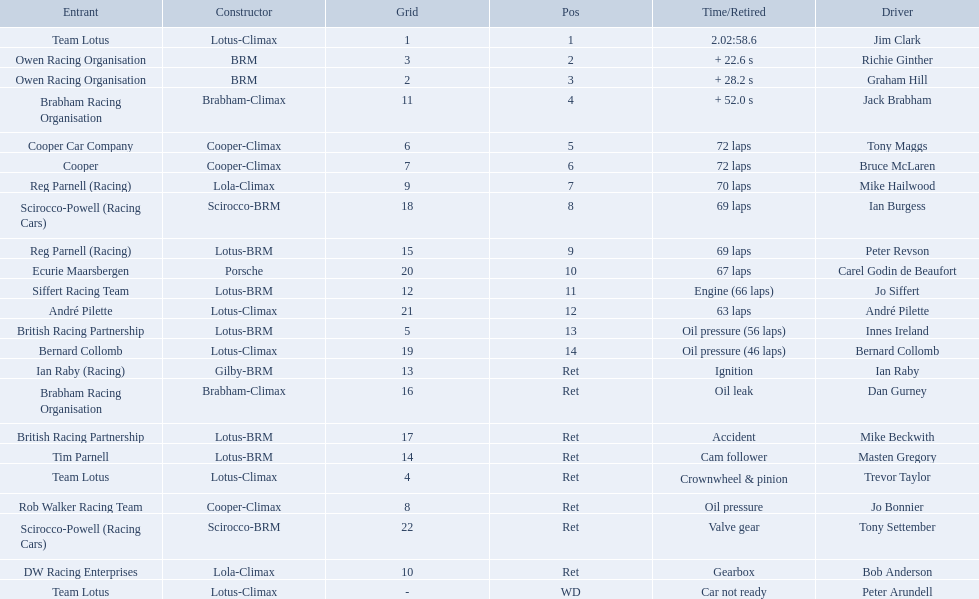Who are all the drivers? Jim Clark, Richie Ginther, Graham Hill, Jack Brabham, Tony Maggs, Bruce McLaren, Mike Hailwood, Ian Burgess, Peter Revson, Carel Godin de Beaufort, Jo Siffert, André Pilette, Innes Ireland, Bernard Collomb, Ian Raby, Dan Gurney, Mike Beckwith, Masten Gregory, Trevor Taylor, Jo Bonnier, Tony Settember, Bob Anderson, Peter Arundell. What position were they in? 1, 2, 3, 4, 5, 6, 7, 8, 9, 10, 11, 12, 13, 14, Ret, Ret, Ret, Ret, Ret, Ret, Ret, Ret, WD. What about just tony maggs and jo siffert? 5, 11. And between them, which driver came in earlier? Tony Maggs. 